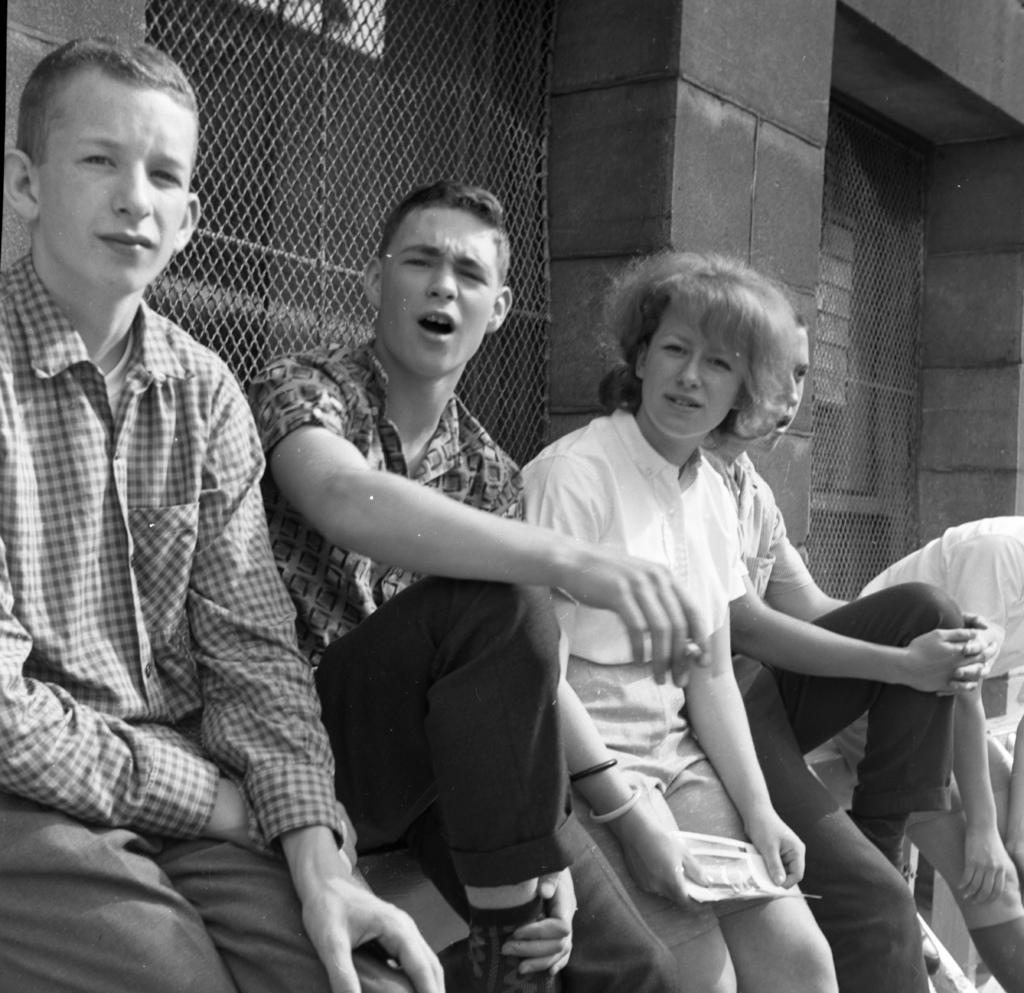What is the color scheme of the image? The image is black and white. Can you describe the people in the image? There is a group of people in the image, and they are sitting beside a metal grill. What is the woman in the image holding? The woman is holding some papers. What can be seen in the background of the image? There is a wall visible in the background. What direction is the owl facing in the image? There is no owl present in the image. What holiday is being celebrated in the image? The image does not depict any specific holiday. 